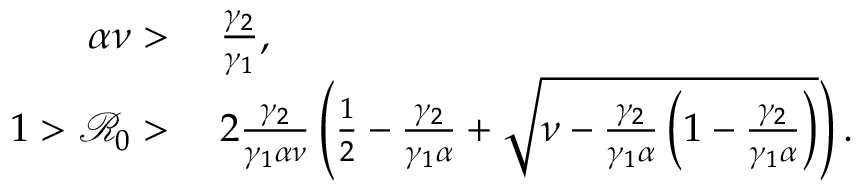Convert formula to latex. <formula><loc_0><loc_0><loc_500><loc_500>\begin{array} { r l } { \alpha \nu > } & { \, \frac { \gamma _ { 2 } } { \gamma _ { 1 } } , } \\ { 1 > \mathcal { R } _ { 0 } > } & { \, 2 \frac { \gamma _ { 2 } } { \gamma _ { 1 } \alpha \nu } \left ( \frac { 1 } { 2 } - \frac { \gamma _ { 2 } } { \gamma _ { 1 } \alpha } + \sqrt { \nu - \frac { \gamma _ { 2 } } { \gamma _ { 1 } \alpha } \left ( 1 - \frac { \gamma _ { 2 } } { \gamma _ { 1 } \alpha } \right ) } \right ) . } \end{array}</formula> 